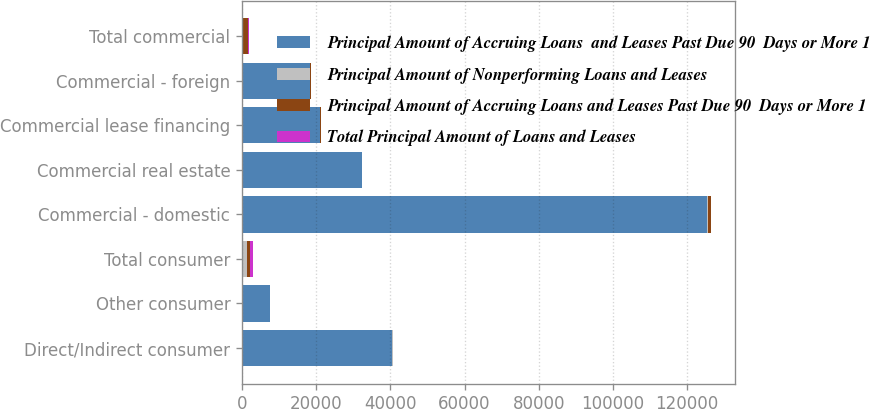Convert chart to OTSL. <chart><loc_0><loc_0><loc_500><loc_500><stacked_bar_chart><ecel><fcel>Direct/Indirect consumer<fcel>Other consumer<fcel>Total consumer<fcel>Commercial - domestic<fcel>Commercial real estate<fcel>Commercial lease financing<fcel>Commercial - foreign<fcel>Total commercial<nl><fcel>Principal Amount of Accruing Loans  and Leases Past Due 90  Days or More 1<fcel>40513<fcel>7439<fcel>129.5<fcel>125432<fcel>32319<fcel>21115<fcel>18401<fcel>129.5<nl><fcel>Principal Amount of Nonperforming Loans and Leases<fcel>58<fcel>23<fcel>1307<fcel>121<fcel>1<fcel>14<fcel>2<fcel>138<nl><fcel>Principal Amount of Accruing Loans and Leases Past Due 90  Days or More 1<fcel>33<fcel>85<fcel>738<fcel>855<fcel>87<fcel>266<fcel>267<fcel>1475<nl><fcel>Total Principal Amount of Loans and Leases<fcel>47<fcel>35<fcel>729<fcel>108<fcel>23<fcel>2<fcel>29<fcel>162<nl></chart> 